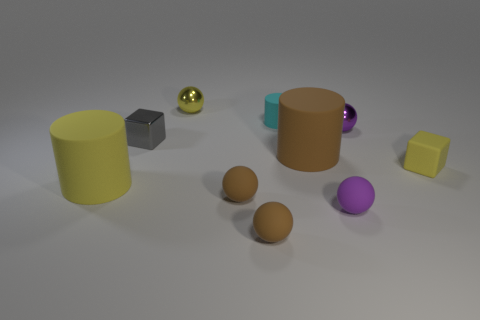There is a yellow thing on the left side of the small yellow thing that is behind the small yellow block; what is its shape?
Offer a terse response. Cylinder. There is a cylinder that is to the left of the large brown cylinder and in front of the tiny purple metal object; how big is it?
Ensure brevity in your answer.  Large. Is there a tiny purple shiny thing that has the same shape as the tiny purple matte object?
Your answer should be very brief. Yes. Are there any other things that are the same shape as the tiny gray thing?
Ensure brevity in your answer.  Yes. The purple sphere behind the big cylinder on the left side of the tiny metal sphere behind the small cylinder is made of what material?
Your answer should be compact. Metal. Is there a cyan object of the same size as the yellow metallic sphere?
Ensure brevity in your answer.  Yes. There is a cube that is to the left of the large cylinder behind the yellow cube; what color is it?
Your answer should be very brief. Gray. What number of small purple shiny spheres are there?
Keep it short and to the point. 1. Is the tiny cylinder the same color as the matte block?
Ensure brevity in your answer.  No. Is the number of tiny cyan things that are left of the tiny rubber cylinder less than the number of purple things that are behind the big brown rubber cylinder?
Your answer should be compact. Yes. 